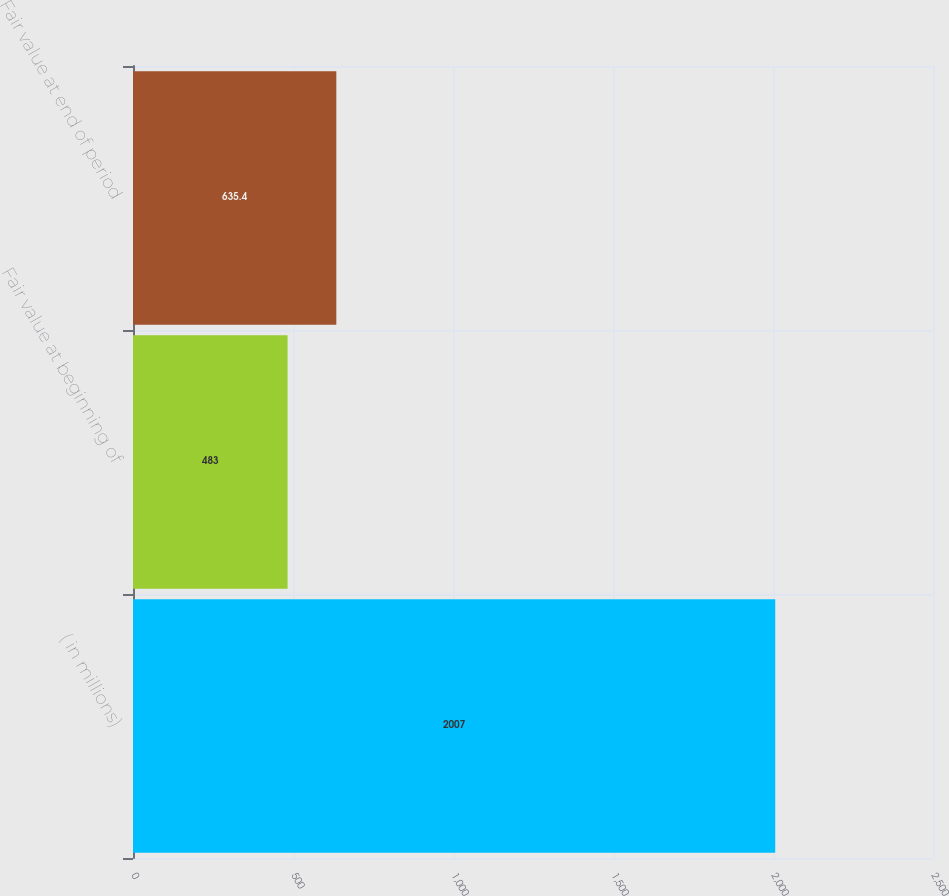<chart> <loc_0><loc_0><loc_500><loc_500><bar_chart><fcel>( in millions)<fcel>Fair value at beginning of<fcel>Fair value at end of period<nl><fcel>2007<fcel>483<fcel>635.4<nl></chart> 